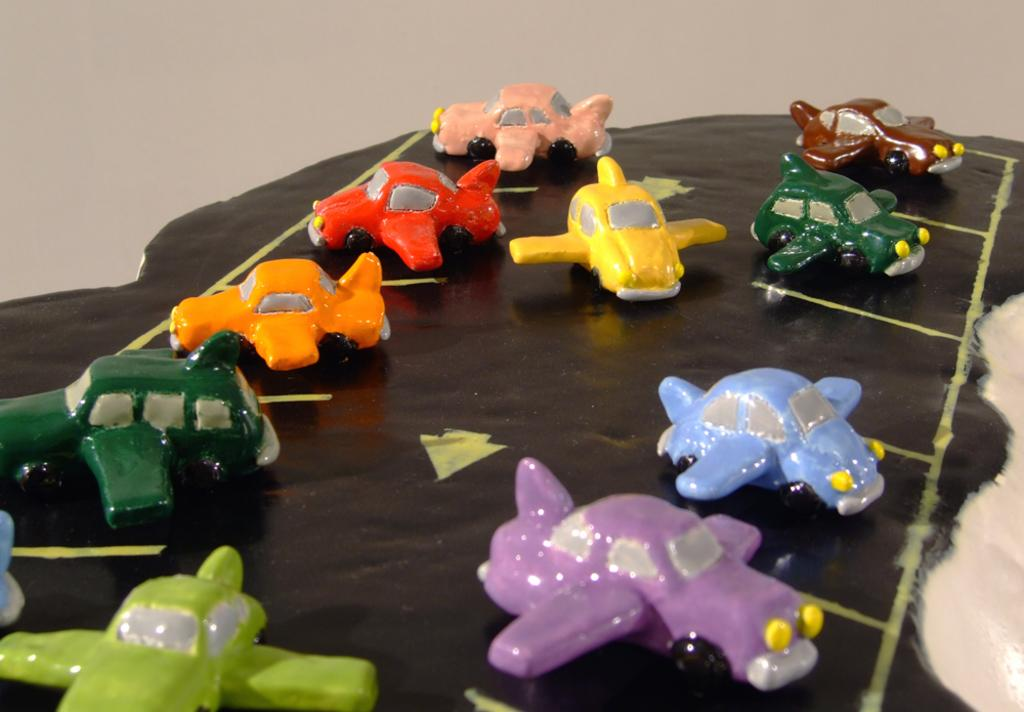What is present on the road in the image? There are toys on the road in the image. What is the toys placed on? The toys are on a black color chart. What can be observed about the toys' appearance? The toys have different colors. Are there any cobwebs visible on the toys in the image? There is no mention of cobwebs in the image, so it cannot be determined if any are present. 